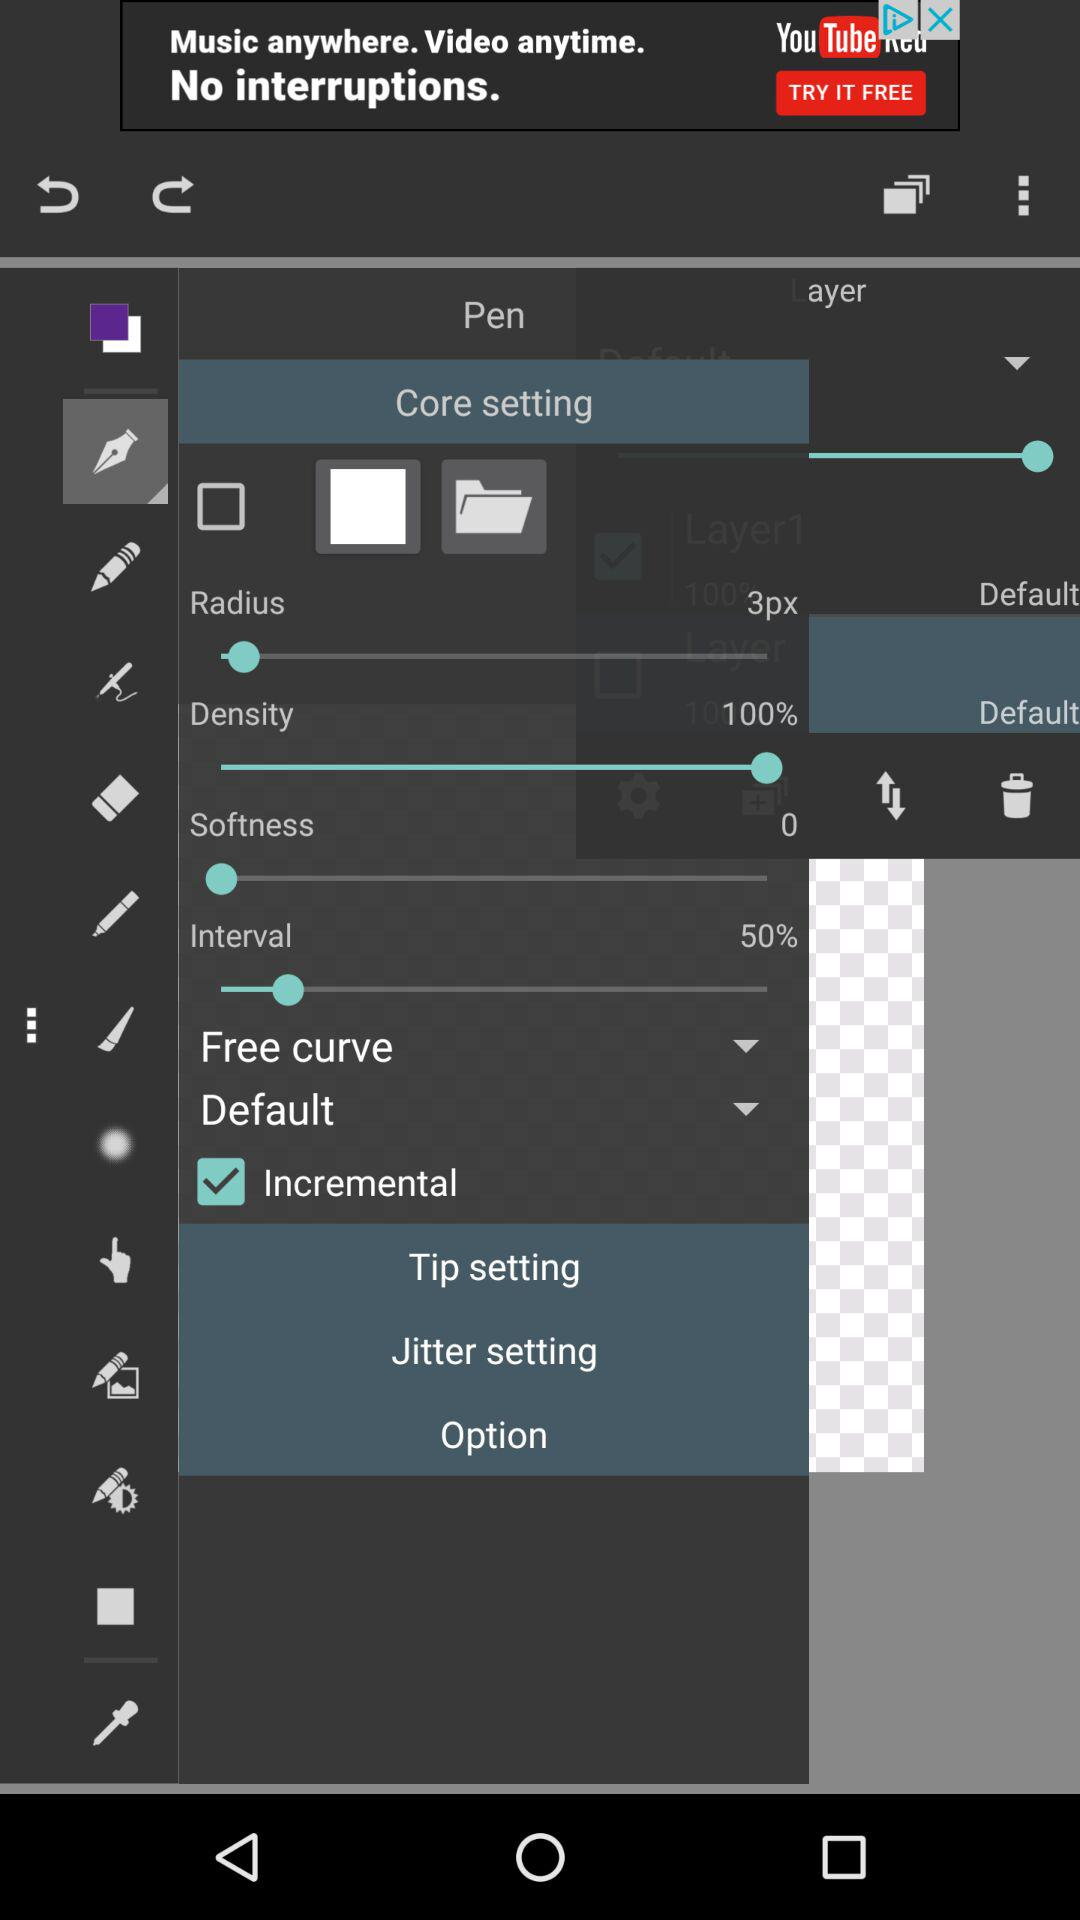What is the setting for the interval? The setting for the interval is 50%. 